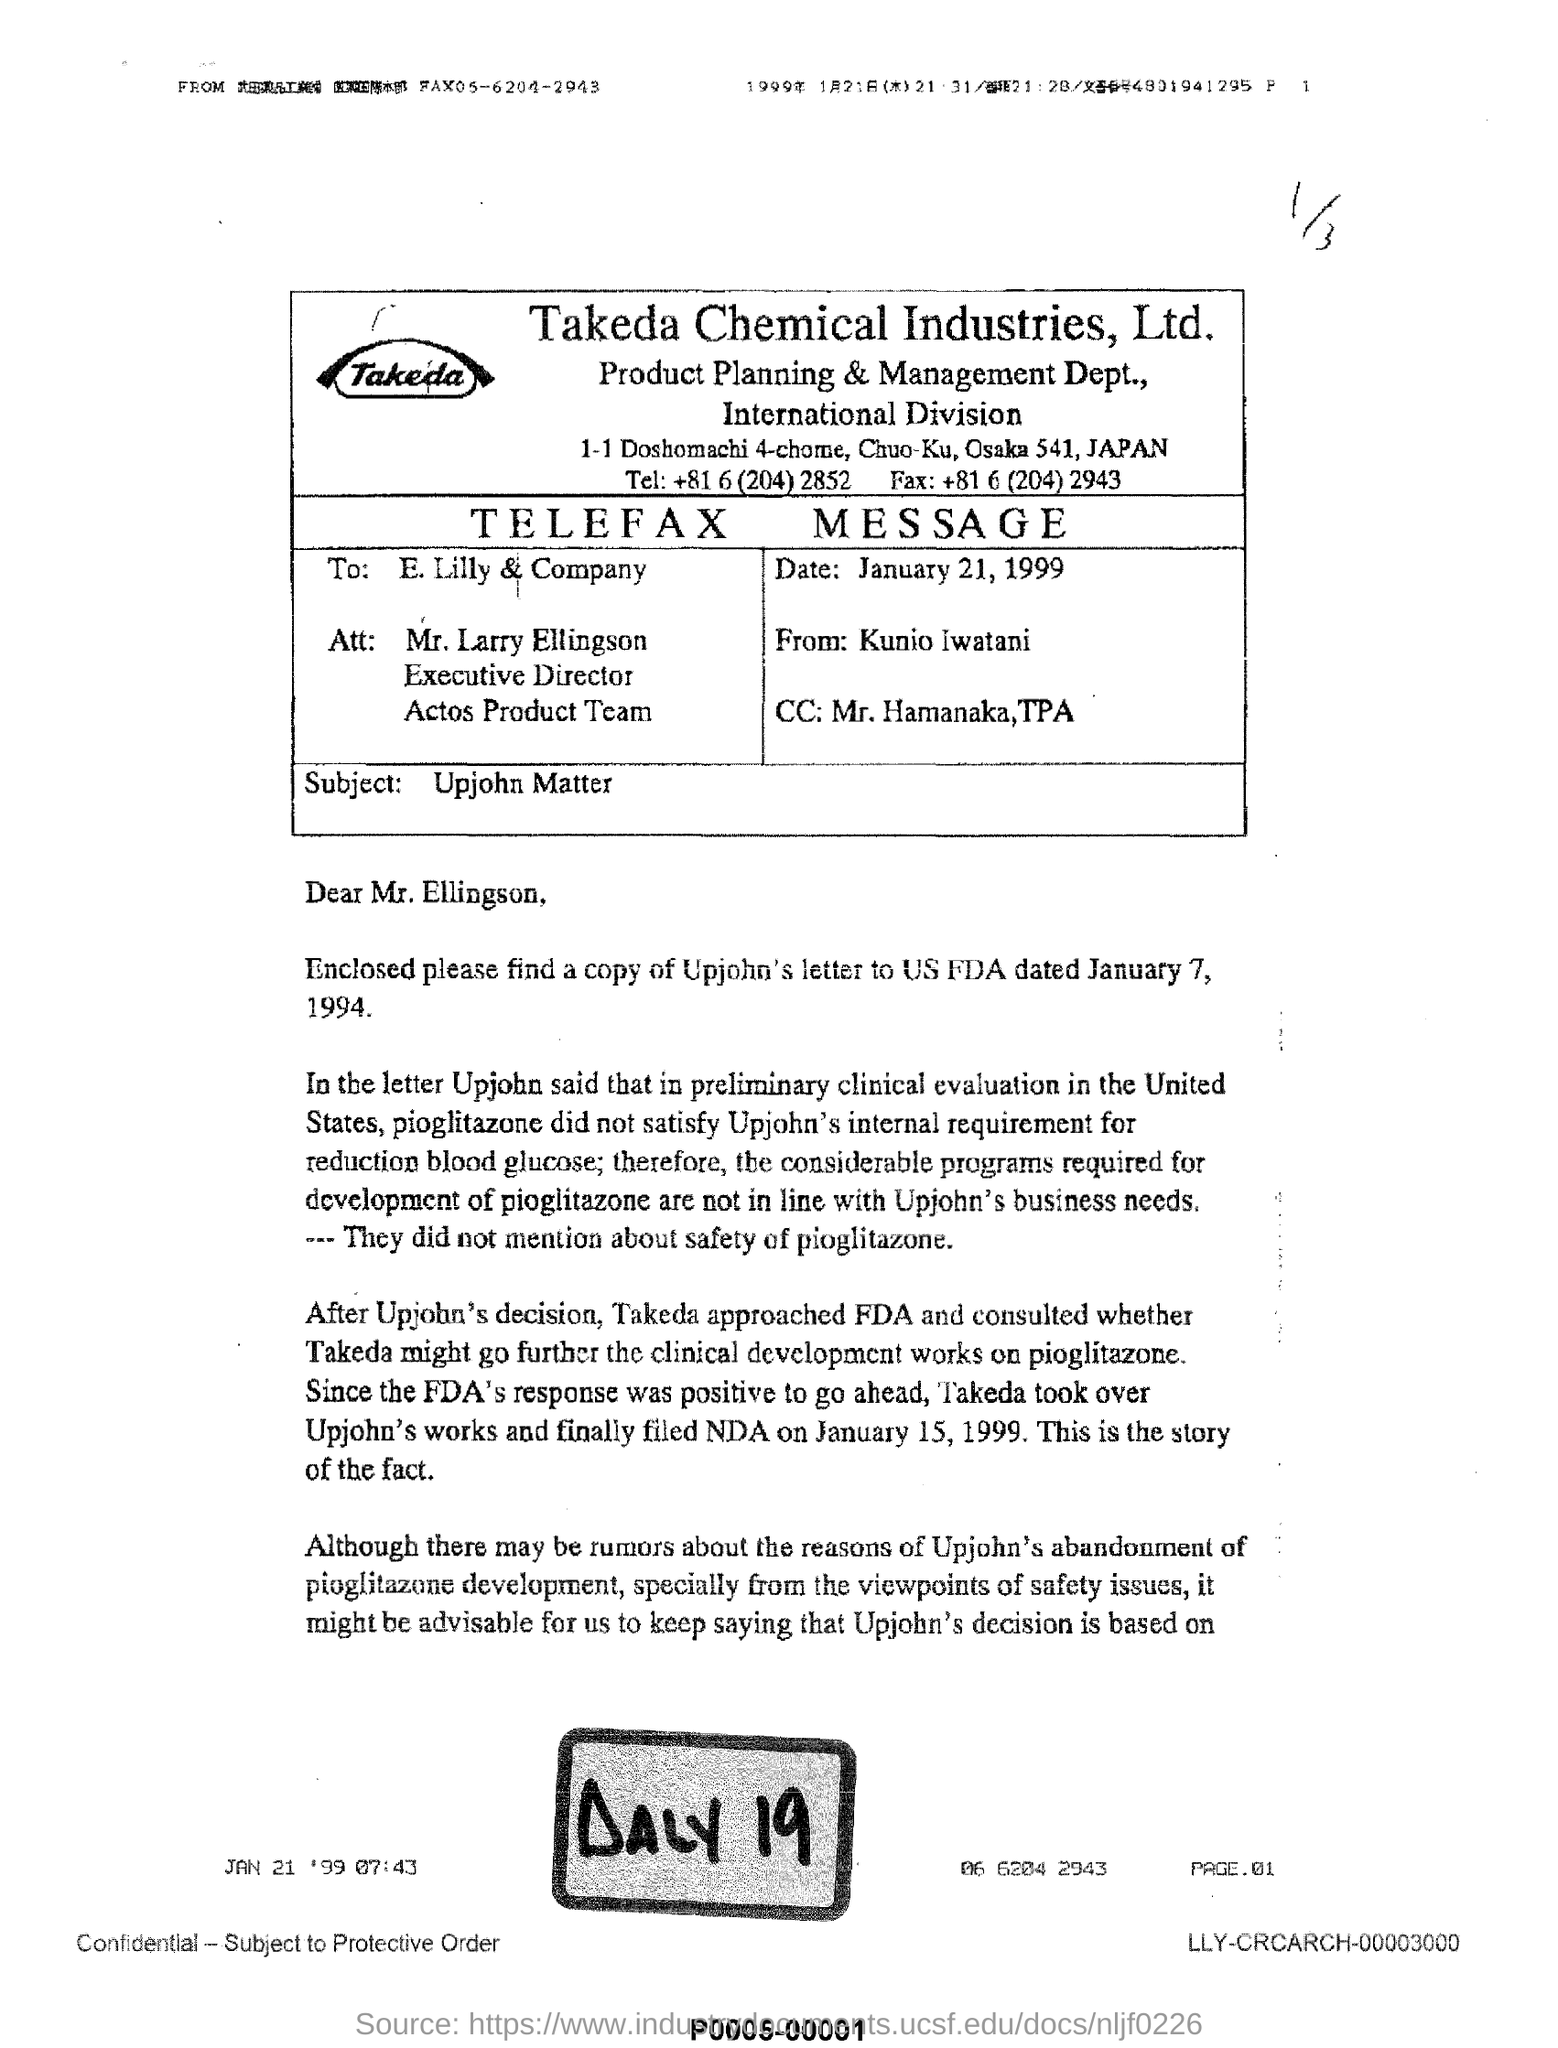Specify some key components in this picture. The document is addressed to Mr. Larry Ellingson. The text in large, bold letters at the bottom reads "DALY 19..". This document was written by Kunio Iwatani. The date mentioned is January 21, 1999. 